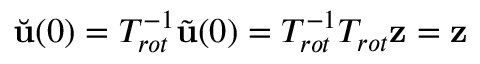Convert formula to latex. <formula><loc_0><loc_0><loc_500><loc_500>\breve { u } ( 0 ) = T _ { r o t } ^ { - 1 } \tilde { u } ( 0 ) = T _ { r o t } ^ { - 1 } T _ { r o t } z = z</formula> 